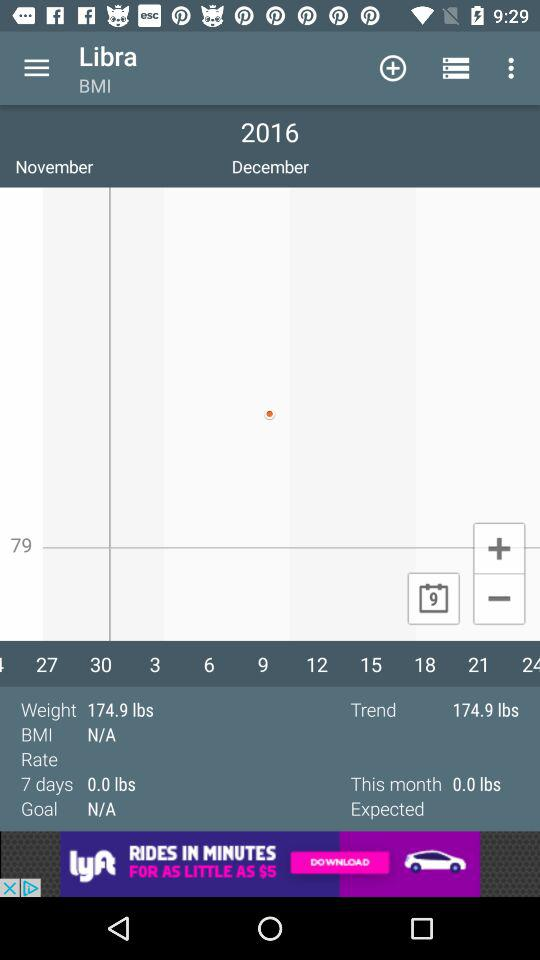What is the BMI of the user?
Answer the question using a single word or phrase. N/A 